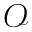Convert formula to latex. <formula><loc_0><loc_0><loc_500><loc_500>\mathcal { O }</formula> 